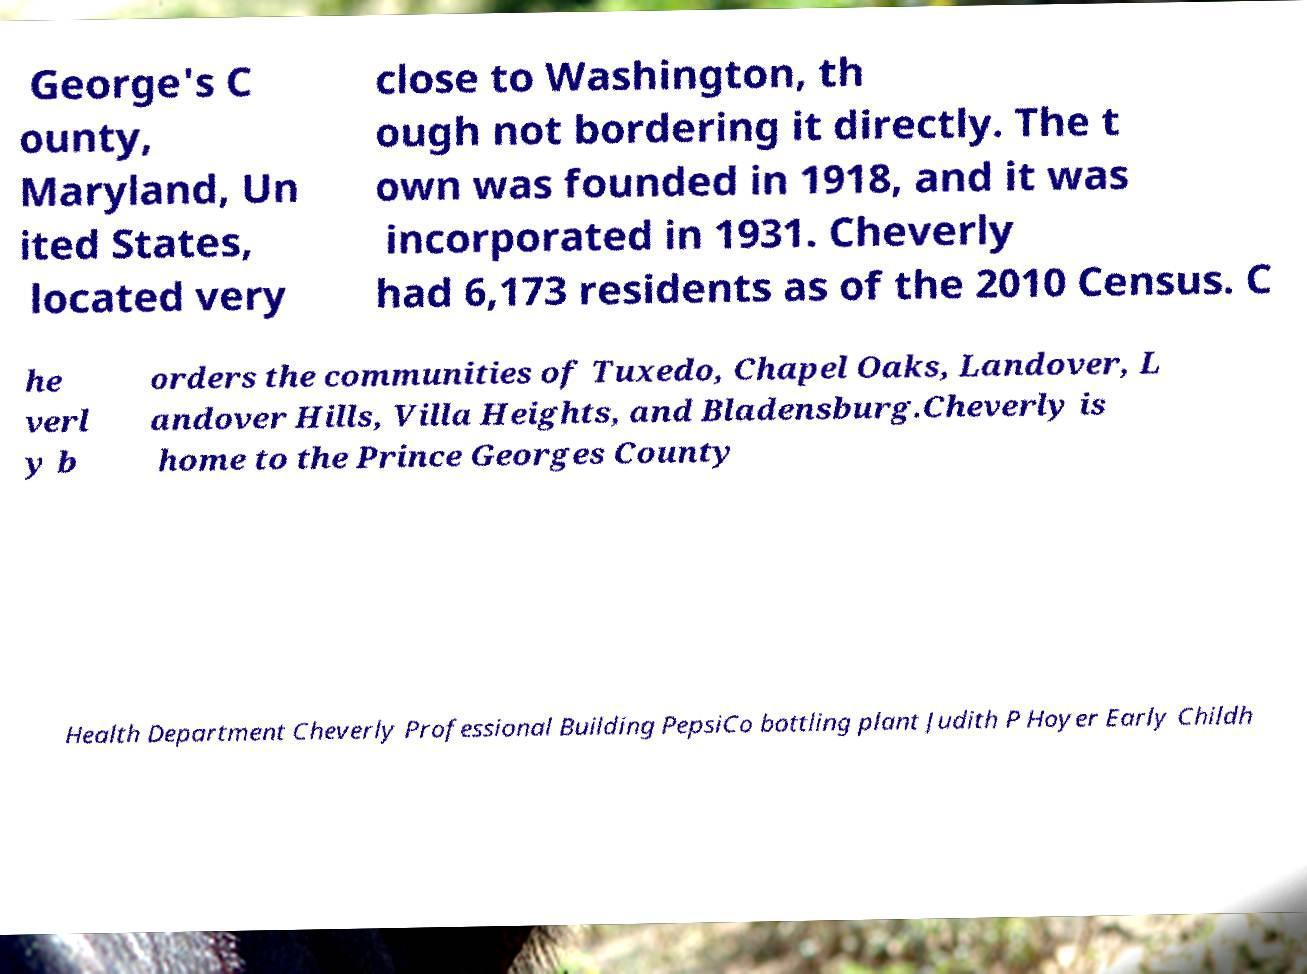What messages or text are displayed in this image? I need them in a readable, typed format. George's C ounty, Maryland, Un ited States, located very close to Washington, th ough not bordering it directly. The t own was founded in 1918, and it was incorporated in 1931. Cheverly had 6,173 residents as of the 2010 Census. C he verl y b orders the communities of Tuxedo, Chapel Oaks, Landover, L andover Hills, Villa Heights, and Bladensburg.Cheverly is home to the Prince Georges County Health Department Cheverly Professional Building PepsiCo bottling plant Judith P Hoyer Early Childh 